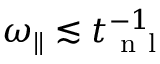<formula> <loc_0><loc_0><loc_500><loc_500>\omega _ { \| } \lesssim t _ { n l } ^ { - 1 }</formula> 